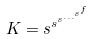Convert formula to latex. <formula><loc_0><loc_0><loc_500><loc_500>K = s ^ { s ^ { s ^ { \dots ^ { s ^ { f } } } } }</formula> 